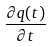Convert formula to latex. <formula><loc_0><loc_0><loc_500><loc_500>\frac { \partial q ( t ) } { \partial t }</formula> 